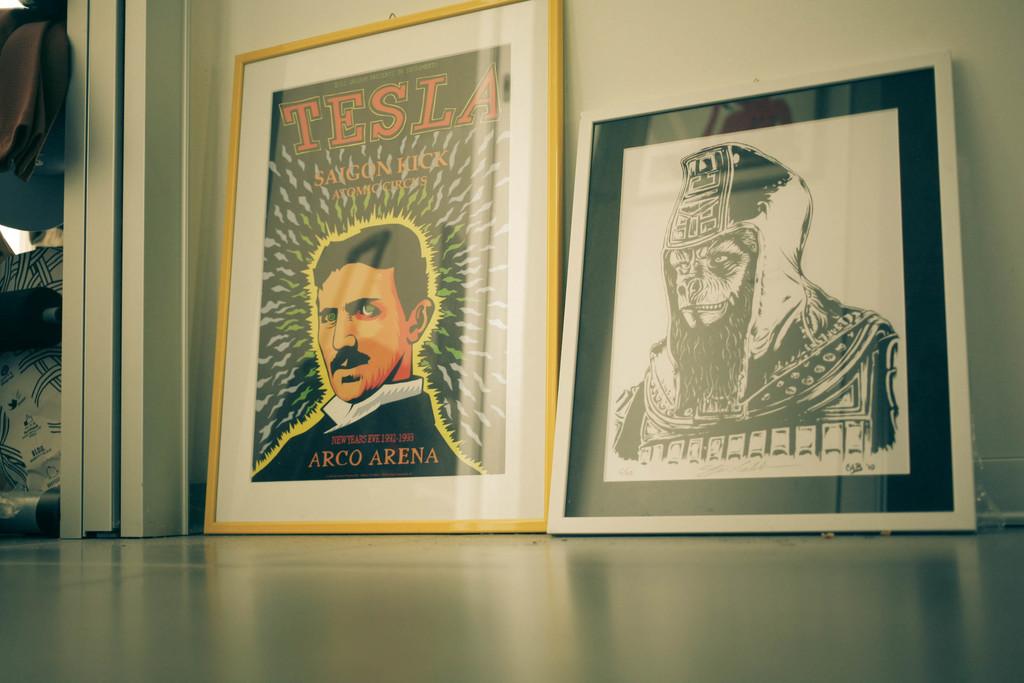What famous person is in this picture?
Ensure brevity in your answer.  Tesla. 